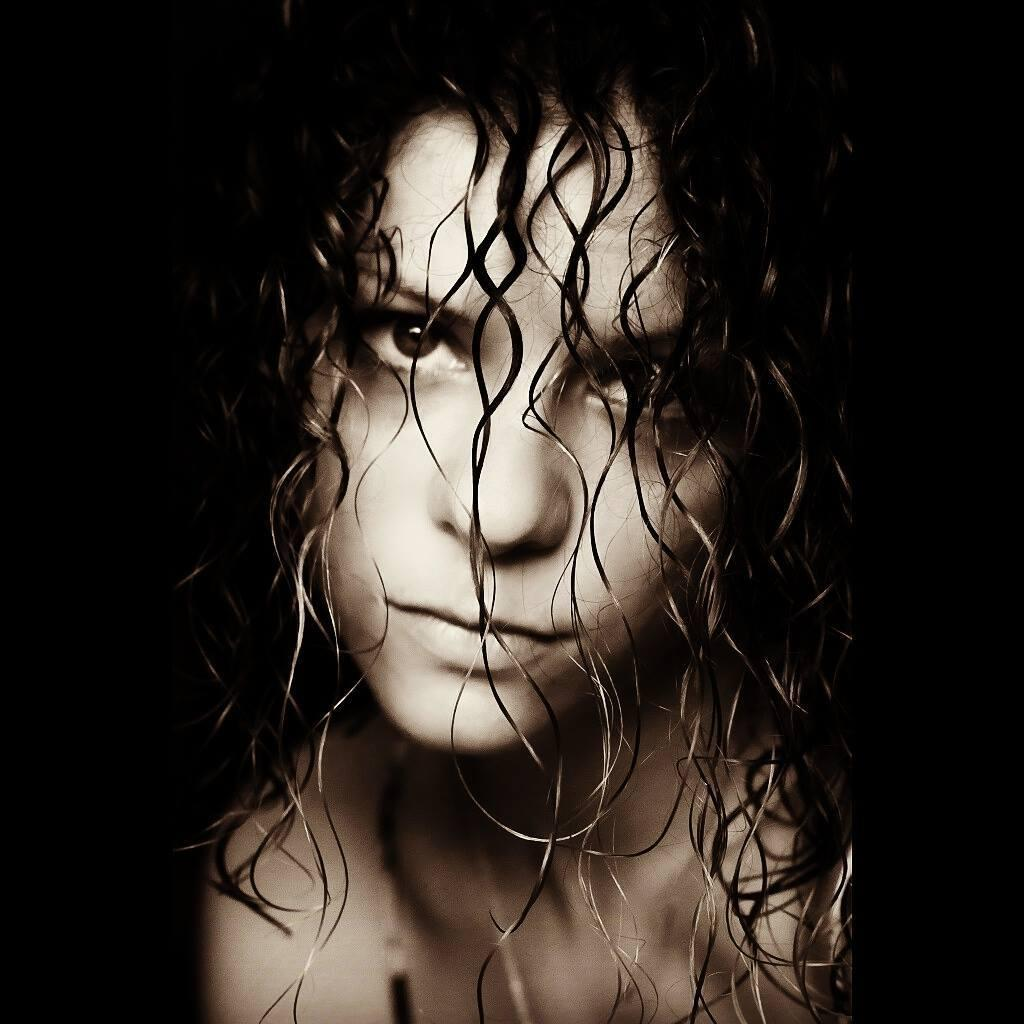What is the main subject of the image? There is a person in the image. Can you describe the person's hair? The person has loose hair. What can be observed about the background of the image? The background of the image is dark. What is the name of the servant in the image? There is no servant present in the image, and therefore no name can be provided. What type of mitten is the person wearing in the image? There is no mitten visible in the image. 